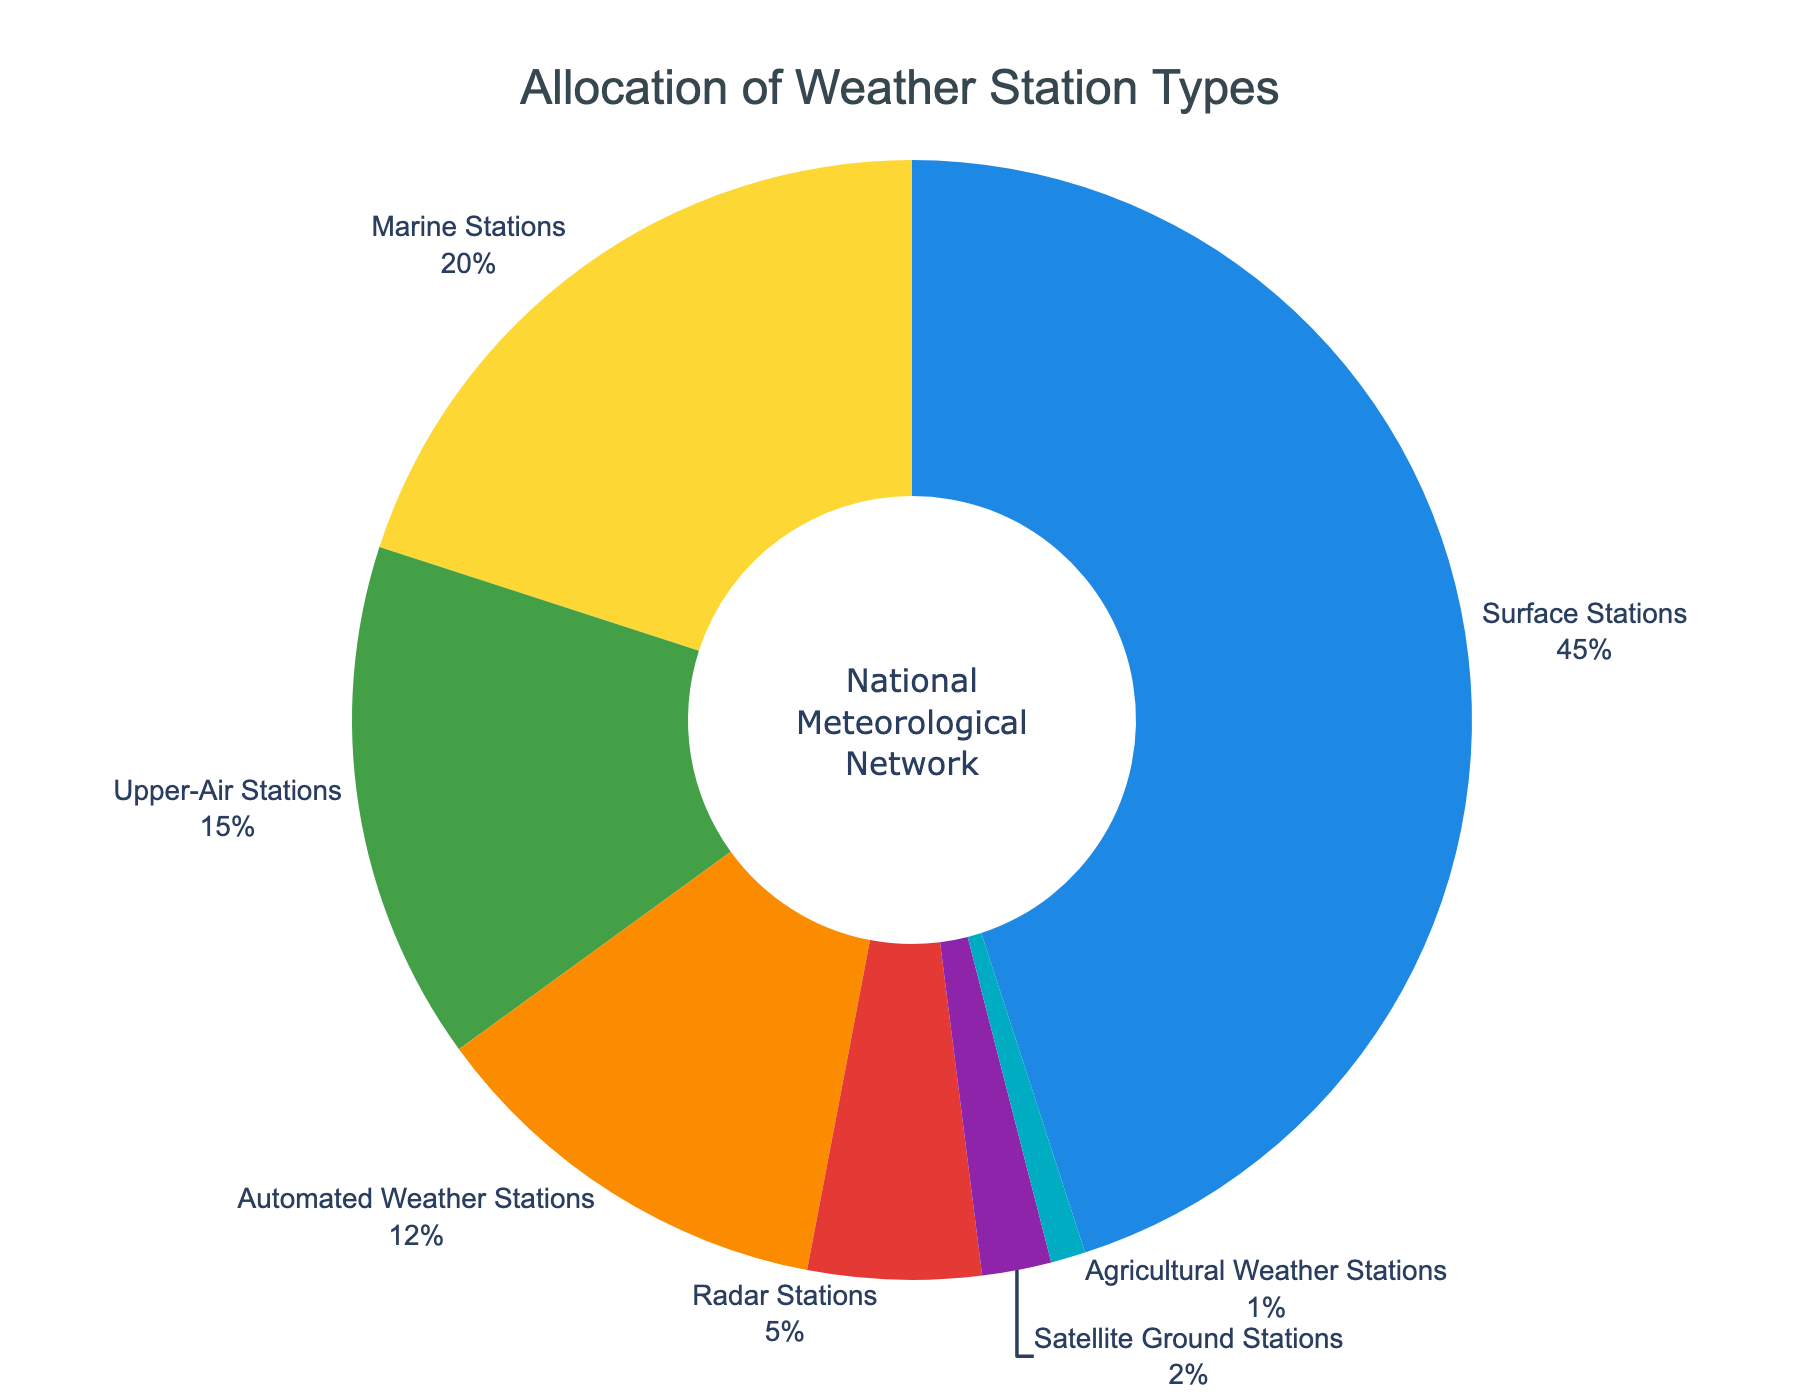What percentage of the weather stations are Automated Weather Stations? Refer to the pie chart. Automated Weather Stations are represented with a percentage label of 12%.
Answer: 12% How much larger is the percentage of Surface Stations compared to Marine Stations? The percentage of Surface Stations is 45%, and the percentage of Marine Stations is 20%. Subtract the percentage of Marine Stations from the percentage of Surface Stations: 45% - 20% = 25%.
Answer: 25% What is the combined percentage of Upper-Air Stations, Radar Stations, and Satellite Ground Stations? Sum the percentages of Upper-Air Stations (15%), Radar Stations (5%), and Satellite Ground Stations (2%): 15% + 5% + 2% = 22%.
Answer: 22% Are there more Marine Stations or Automated Weather Stations? The pie chart shows Marine Stations with 20% and Automated Weather Stations with 12%. Since 20% is greater than 12%, there are more Marine Stations.
Answer: Marine Stations What type of weather station occupies the smallest percentage of the national meteorological network? The pie chart shows Agricultural Weather Stations with the smallest slice and a percentage label of 1%.
Answer: Agricultural Weather Stations What is the difference in percentage between Automated Weather Stations and Upper-Air Stations? Compare the percentages: Automated Weather Stations are 12% and Upper-Air Stations are 15%. The difference is 15% - 12% = 3%.
Answer: 3% Of the types of weather stations that make up less than 10% of the network, which type has the highest percentage? The weather stations making up less than 10% are Radar Stations at 5%, Satellite Ground Stations at 2%, and Agricultural Weather Stations at 1%. The highest of these is Radar Stations.
Answer: Radar Stations What percentage of the network is composed of Surface Stations and Radar Stations combined? Add the percentages of Surface Stations (45%) and Radar Stations (5%): 45% + 5% = 50%.
Answer: 50% Which weather station types together make up exactly 20% of the network? The pie chart shows Marine Stations alone have a percentage of 20%, so no combination of types equals exactly 20%.
Answer: Marine Stations How many types of weather stations are represented by percentages in single digits? The pie chart shows the following types with single-digit percentages: Radar Stations (5%), Satellite Ground Stations (2%), and Agricultural Weather Stations (1%). This totals to three types.
Answer: 3 